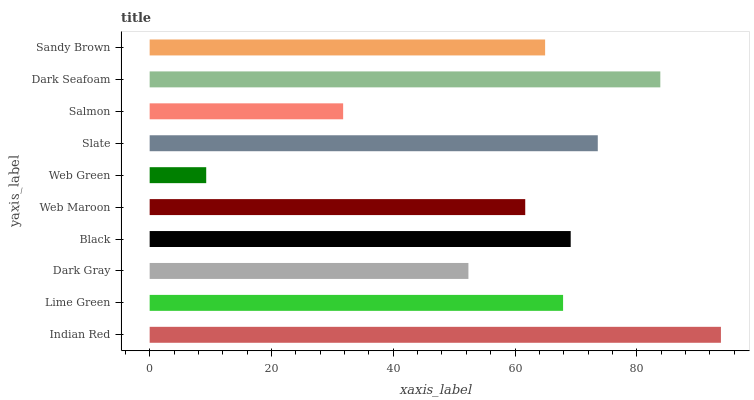Is Web Green the minimum?
Answer yes or no. Yes. Is Indian Red the maximum?
Answer yes or no. Yes. Is Lime Green the minimum?
Answer yes or no. No. Is Lime Green the maximum?
Answer yes or no. No. Is Indian Red greater than Lime Green?
Answer yes or no. Yes. Is Lime Green less than Indian Red?
Answer yes or no. Yes. Is Lime Green greater than Indian Red?
Answer yes or no. No. Is Indian Red less than Lime Green?
Answer yes or no. No. Is Lime Green the high median?
Answer yes or no. Yes. Is Sandy Brown the low median?
Answer yes or no. Yes. Is Dark Gray the high median?
Answer yes or no. No. Is Dark Seafoam the low median?
Answer yes or no. No. 